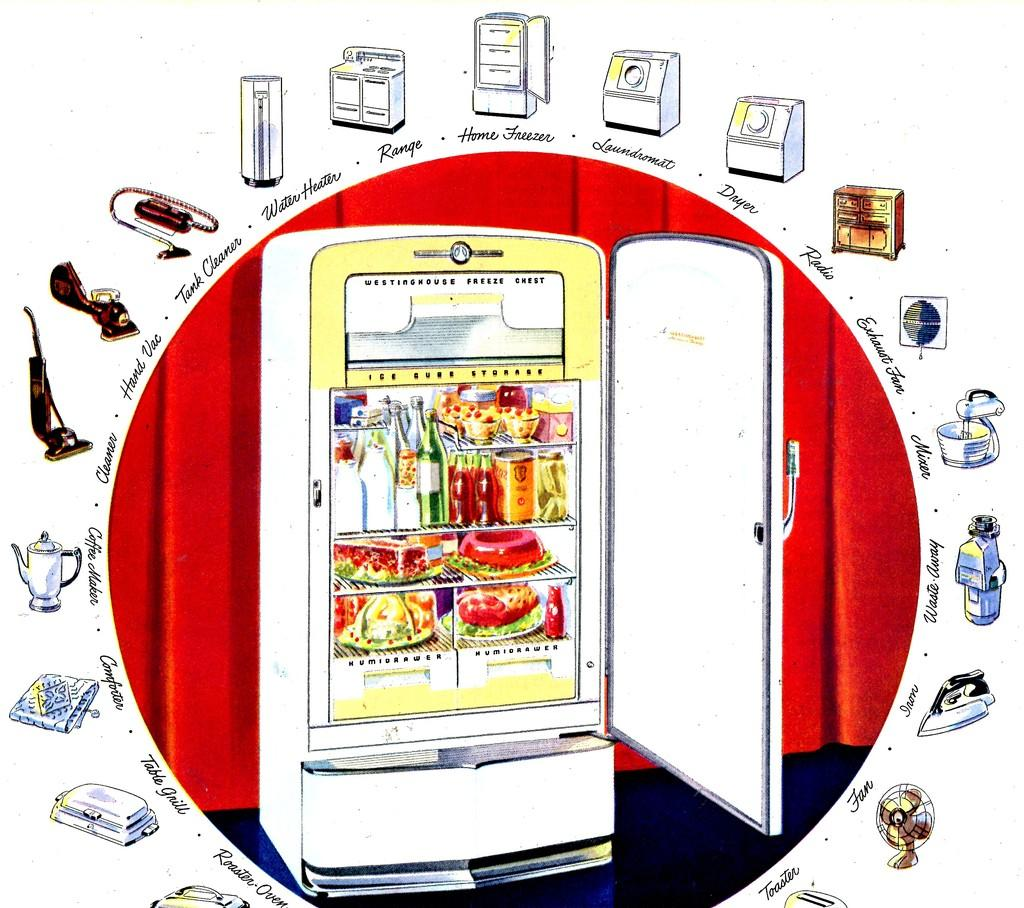Provide a one-sentence caption for the provided image. an ad for Westinghouse freeze chest shows other appliances too. 